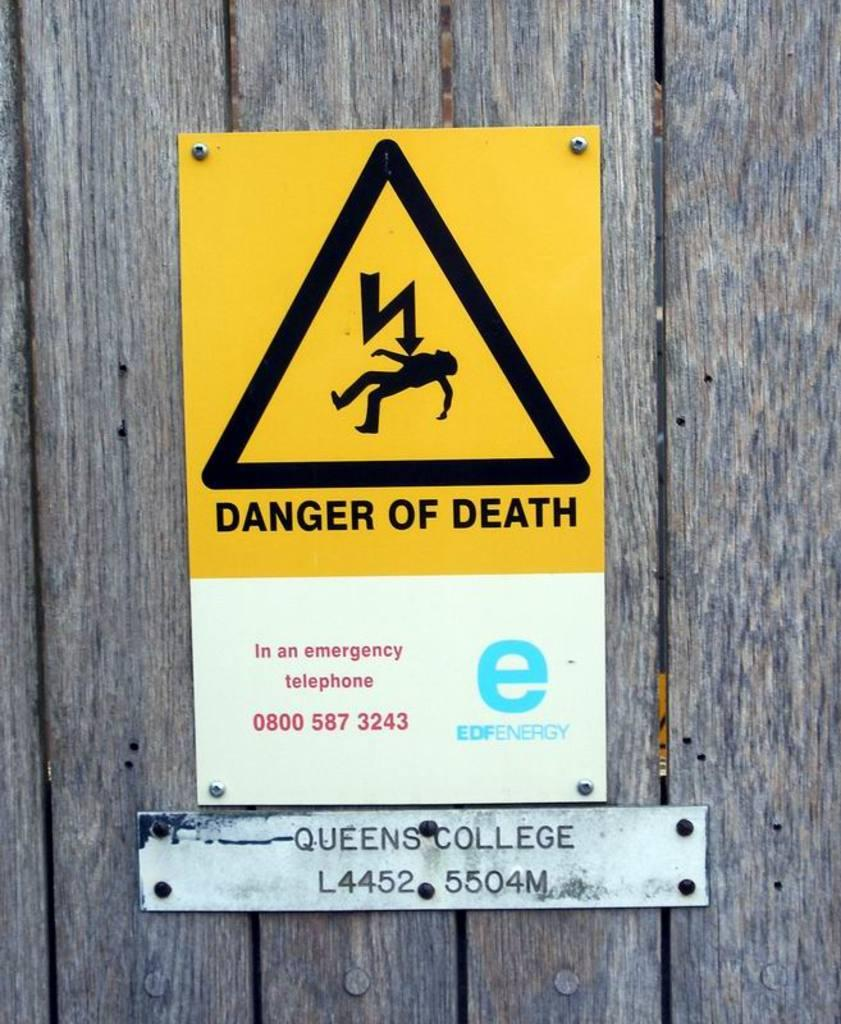<image>
Provide a brief description of the given image. Danger of death sign on a wooden fence. 